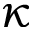<formula> <loc_0><loc_0><loc_500><loc_500>\kappa</formula> 